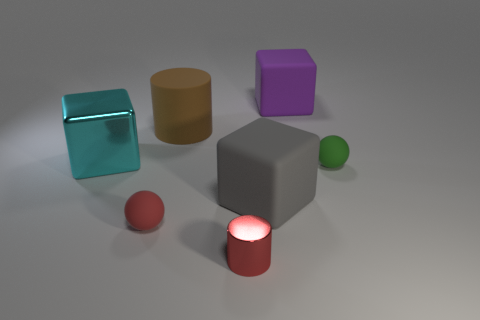What number of small gray metallic cylinders are there?
Your response must be concise. 0. What is the color of the large cube that is made of the same material as the small cylinder?
Ensure brevity in your answer.  Cyan. Is the number of metallic cylinders greater than the number of matte blocks?
Give a very brief answer. No. There is a cube that is both in front of the purple thing and to the right of the brown matte object; what size is it?
Ensure brevity in your answer.  Large. What material is the tiny ball that is the same color as the tiny metal thing?
Your response must be concise. Rubber. Are there the same number of matte balls that are to the left of the small green sphere and big gray things?
Keep it short and to the point. Yes. Do the gray cube and the green sphere have the same size?
Make the answer very short. No. What color is the object that is both in front of the green sphere and to the right of the red cylinder?
Your answer should be very brief. Gray. The tiny thing on the right side of the large rubber cube that is in front of the big cyan metal block is made of what material?
Your answer should be compact. Rubber. There is a red metal thing that is the same shape as the brown rubber object; what is its size?
Keep it short and to the point. Small. 